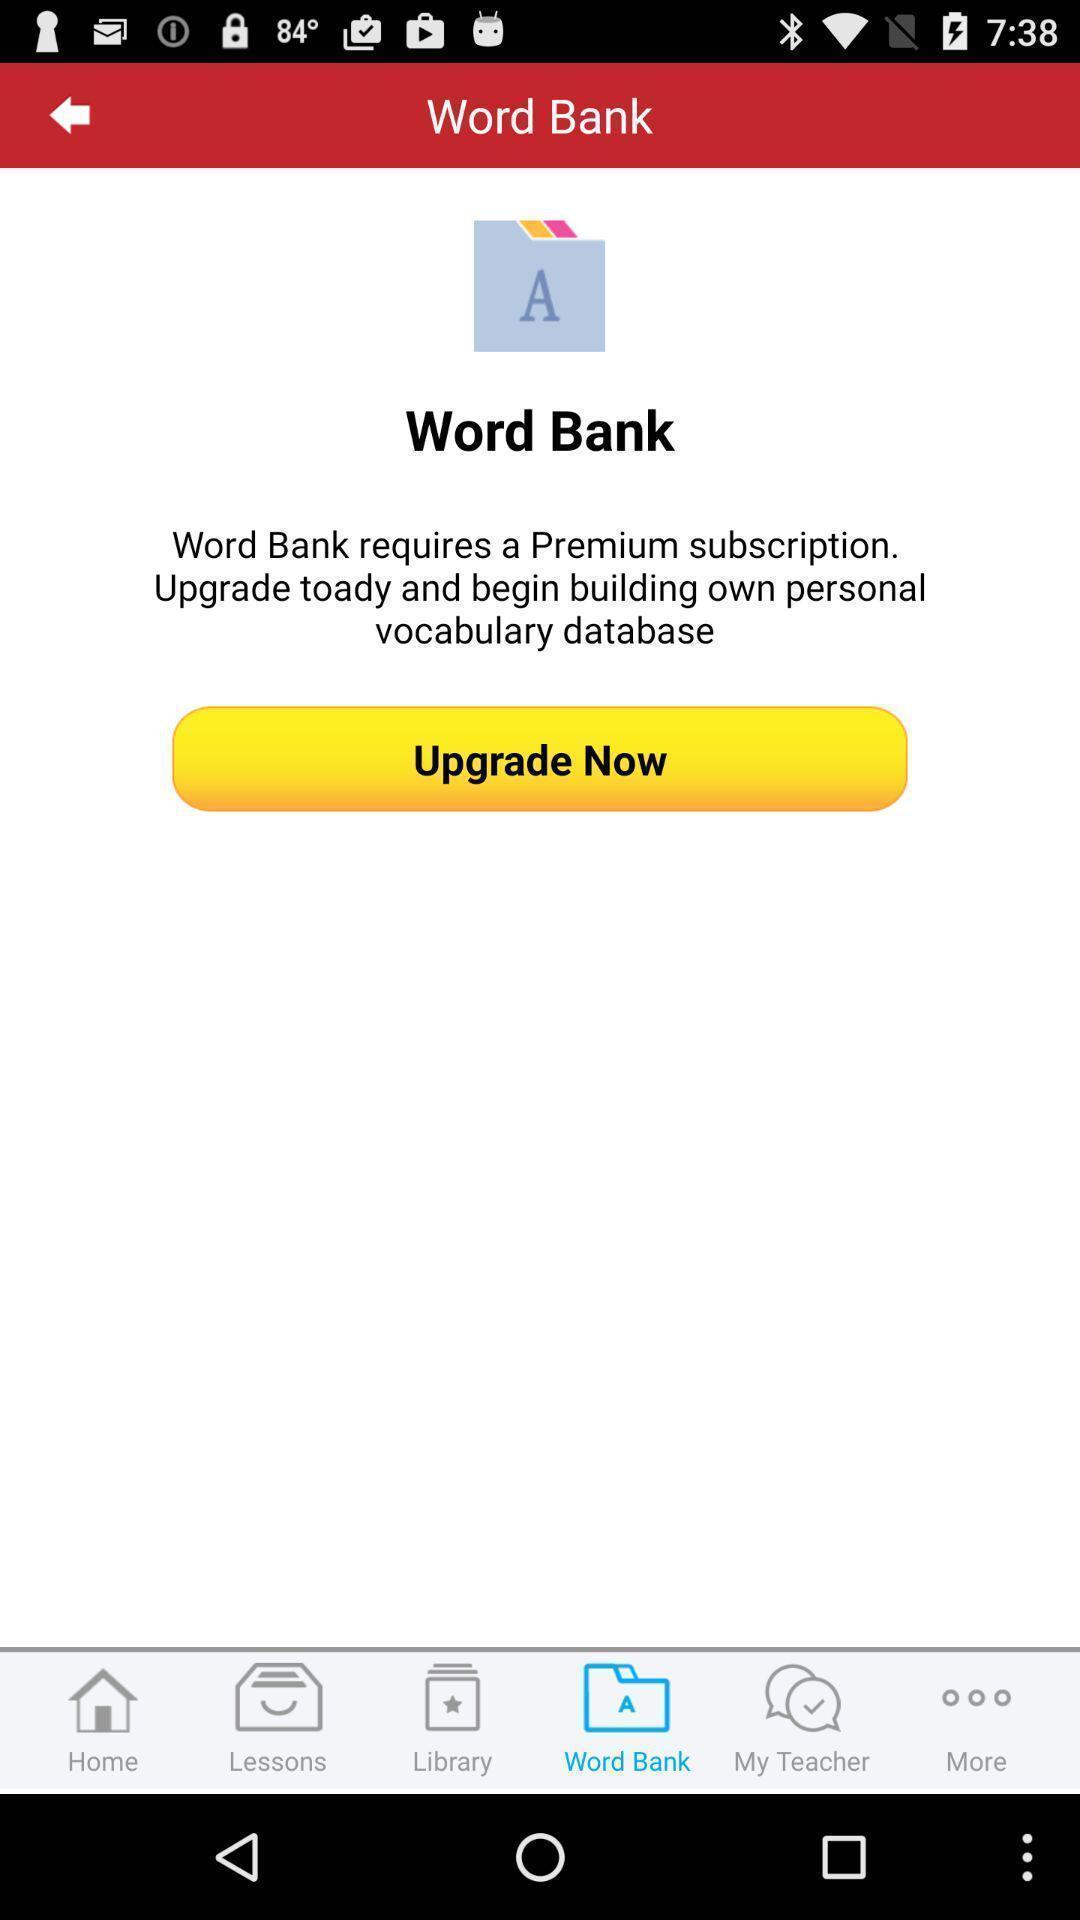Describe the visual elements of this screenshot. Page displaying to upgrade the word bank. 